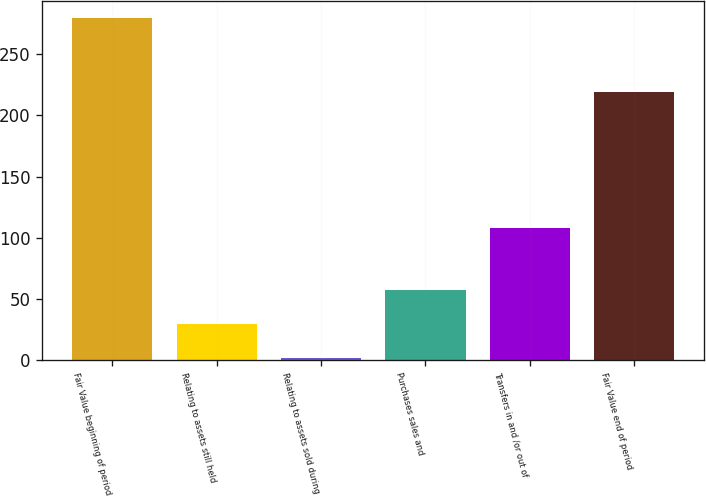Convert chart. <chart><loc_0><loc_0><loc_500><loc_500><bar_chart><fcel>Fair Value beginning of period<fcel>Relating to assets still held<fcel>Relating to assets sold during<fcel>Purchases sales and<fcel>Transfers in and /or out of<fcel>Fair Value end of period<nl><fcel>280<fcel>28.95<fcel>1.06<fcel>56.84<fcel>108<fcel>219<nl></chart> 